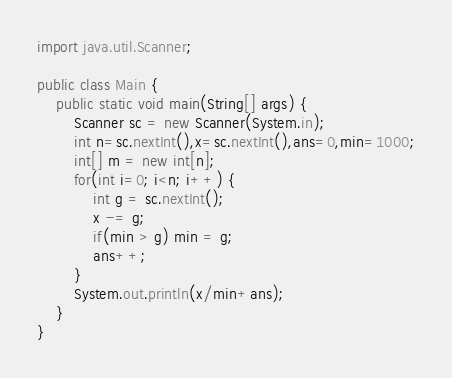<code> <loc_0><loc_0><loc_500><loc_500><_Java_>import java.util.Scanner;

public class Main {
	public static void main(String[] args) {
		Scanner sc = new Scanner(System.in);
		int n=sc.nextInt(),x=sc.nextInt(),ans=0,min=1000;
		int[] m = new int[n];
		for(int i=0; i<n; i++) {
			int g = sc.nextInt();
			x -= g;
			if(min > g) min = g;
			ans++;
		}
		System.out.println(x/min+ans);
	}
}
</code> 